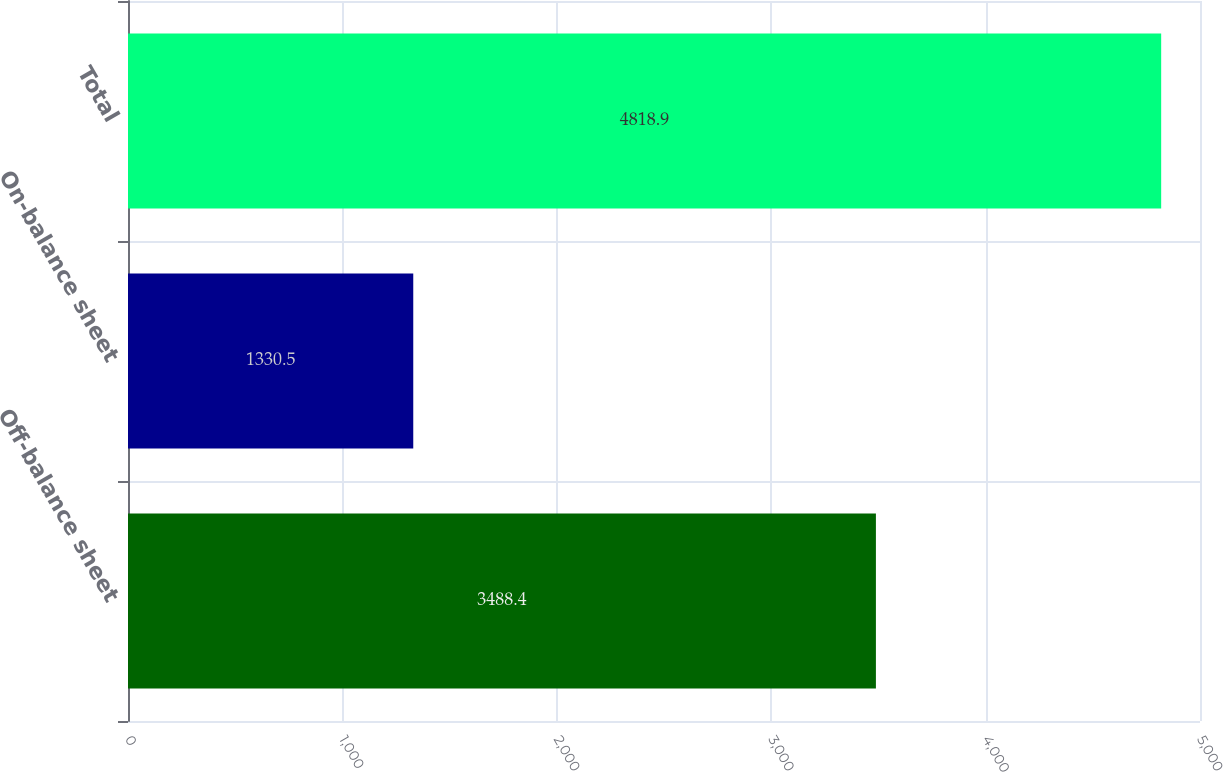<chart> <loc_0><loc_0><loc_500><loc_500><bar_chart><fcel>Off-balance sheet<fcel>On-balance sheet<fcel>Total<nl><fcel>3488.4<fcel>1330.5<fcel>4818.9<nl></chart> 